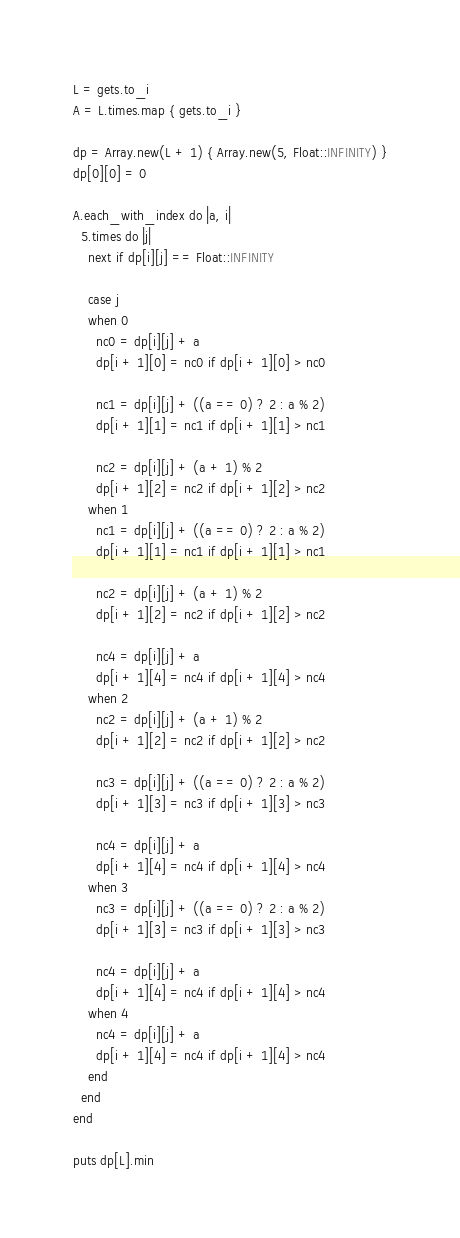Convert code to text. <code><loc_0><loc_0><loc_500><loc_500><_Ruby_>L = gets.to_i
A = L.times.map { gets.to_i }

dp = Array.new(L + 1) { Array.new(5, Float::INFINITY) }
dp[0][0] = 0

A.each_with_index do |a, i|
  5.times do |j|
    next if dp[i][j] == Float::INFINITY

    case j
    when 0
      nc0 = dp[i][j] + a
      dp[i + 1][0] = nc0 if dp[i + 1][0] > nc0

      nc1 = dp[i][j] + ((a == 0) ? 2 : a % 2)
      dp[i + 1][1] = nc1 if dp[i + 1][1] > nc1

      nc2 = dp[i][j] + (a + 1) % 2
      dp[i + 1][2] = nc2 if dp[i + 1][2] > nc2
    when 1
      nc1 = dp[i][j] + ((a == 0) ? 2 : a % 2)
      dp[i + 1][1] = nc1 if dp[i + 1][1] > nc1

      nc2 = dp[i][j] + (a + 1) % 2
      dp[i + 1][2] = nc2 if dp[i + 1][2] > nc2

      nc4 = dp[i][j] + a
      dp[i + 1][4] = nc4 if dp[i + 1][4] > nc4
    when 2
      nc2 = dp[i][j] + (a + 1) % 2
      dp[i + 1][2] = nc2 if dp[i + 1][2] > nc2

      nc3 = dp[i][j] + ((a == 0) ? 2 : a % 2)
      dp[i + 1][3] = nc3 if dp[i + 1][3] > nc3

      nc4 = dp[i][j] + a
      dp[i + 1][4] = nc4 if dp[i + 1][4] > nc4
    when 3
      nc3 = dp[i][j] + ((a == 0) ? 2 : a % 2)
      dp[i + 1][3] = nc3 if dp[i + 1][3] > nc3

      nc4 = dp[i][j] + a
      dp[i + 1][4] = nc4 if dp[i + 1][4] > nc4
    when 4
      nc4 = dp[i][j] + a
      dp[i + 1][4] = nc4 if dp[i + 1][4] > nc4
    end
  end
end

puts dp[L].min
</code> 